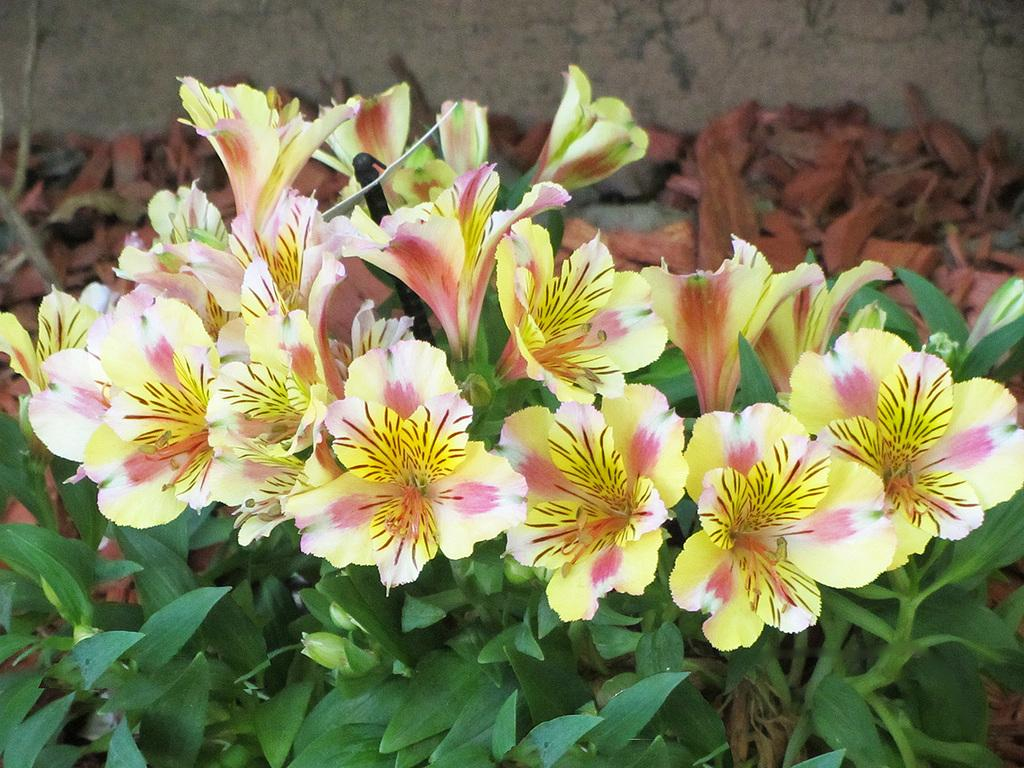What type of living organisms can be seen in the image? Plants and flowers are visible in the image. What is the condition of some of the plant material in the image? There are dried leaves in the image. What type of teaching method is being demonstrated in the image? There is no teaching method or activity present in the image; it features plants and flowers. How can the quietness of the environment be determined from the image? The image does not provide any information about the sound or noise level in the environment. 